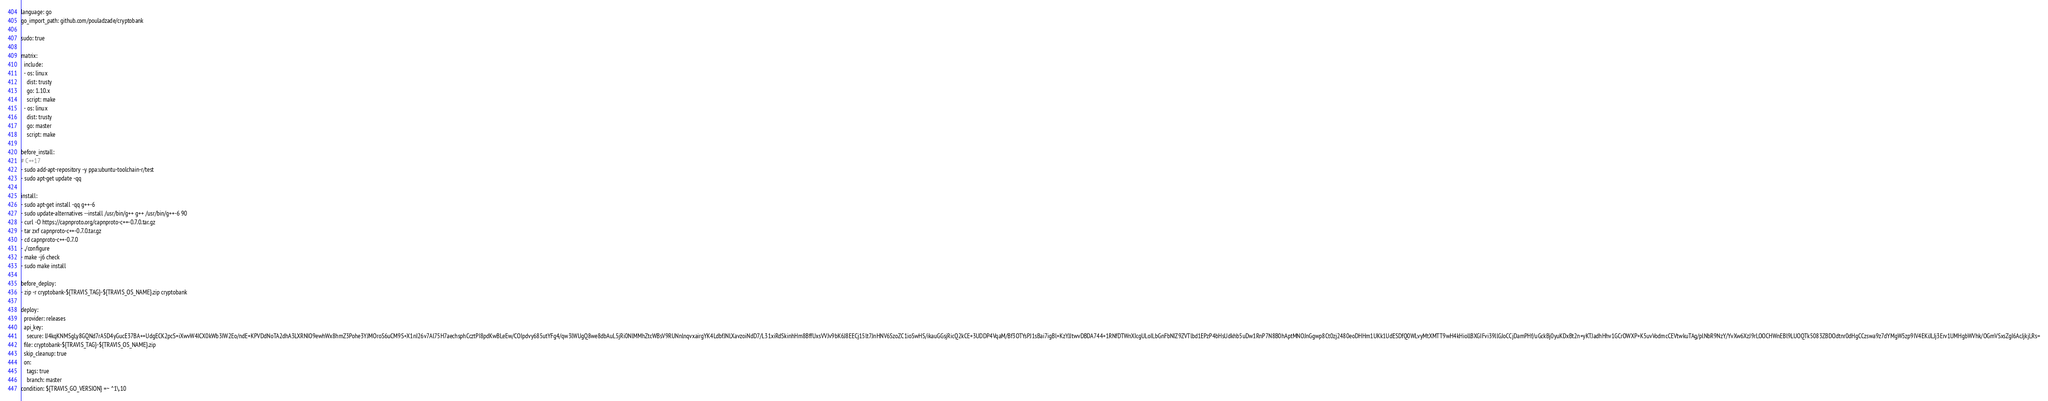Convert code to text. <code><loc_0><loc_0><loc_500><loc_500><_YAML_>language: go
go_import_path: github.com/pouladzade/cryptobank

sudo: true

matrix:
  include:
  - os: linux
    dist: trusty
    go: 1.10.x
    script: make
  - os: linux
    dist: trusty
    go: master
    script: make

before_install:
# C++17
- sudo add-apt-repository -y ppa:ubuntu-toolchain-r/test
- sudo apt-get update -qq

install:
- sudo apt-get install -qq g++-6
- sudo update-alternatives --install /usr/bin/g++ g++ /usr/bin/g++-6 90
- curl -O https://capnproto.org/capnproto-c++-0.7.0.tar.gz
- tar zxf capnproto-c++-0.7.0.tar.gz
- cd capnproto-c++-0.7.0
- ./configure
- make -j6 check
- sudo make install

before_deploy:
- zip -r cryptobank-${TRAVIS_TAG}-${TRAVIS_OS_NAME}.zip cryptobank

deploy:
  provider: releases
  api_key:
    secure: IJ4kqKNMSgLy8GQNd7rA5D4yGucE37BA++UdgECK2pcS+iXwvW4ICX0kWb3IW2Eo/ndE+KPVDdNoTA2dhA3LXRNIO9ewhWx8hmZ3Pohe3YJMOroS6uCM9S+X1nI26v7Al75H7aechsphCcztPI8pdKwBLeEw/COIpdvy685utYFg4/qw3lWUgQ8we8dbAuL5jRi0NlMMhZtcWBsV9RUNnlnqvxairgYK4LdbfJNLXavzoiNdD7/L31xiRdSkinhHm8BffUxsVVJv9bK6J8EECj15lt7JnHNV6SzoZC1ioSwHS/ikauGGsjRicQ2kCE+3UDDP4VqaM/Bf3OTYsPJ1sBai7igBl+KzYJJtwvDBDA744+1RNfDTWnXIcgULoILbGnFbNIZ9ZVTlbd1EPzP4bHsUdkhb5uDw1RnP7N8B0hAptMNOJnGgwp8Ct0zj2480eoDHHm1UKk1UdESDfQ0WLvyMtXMTT9wH4kHiollBXGIFvi39llGJoCCjDamPHf/uGckBj0yuKDxBt2n+yKTJadhHhv1GCrOWXP+K5uvVodmcCEVtwkuTAg/plNbR9NzY/YvXw6XzJ9rLOOCHWnEBl9LUOQTk5083ZBDOdtnr0dHgCCzswa9z7dYMgW5zp9IV4EKiJLJj3Erv1UMHgbWVhk/OGmVSxsZgI6AcJjkjLRs=
  file: cryptobank-${TRAVIS_TAG}-${TRAVIS_OS_NAME}.zip
  skip_cleanup: true
  on:
    tags: true
    branch: master
condition: ${TRAVIS_GO_VERSION} =~ ^1\.10




</code> 